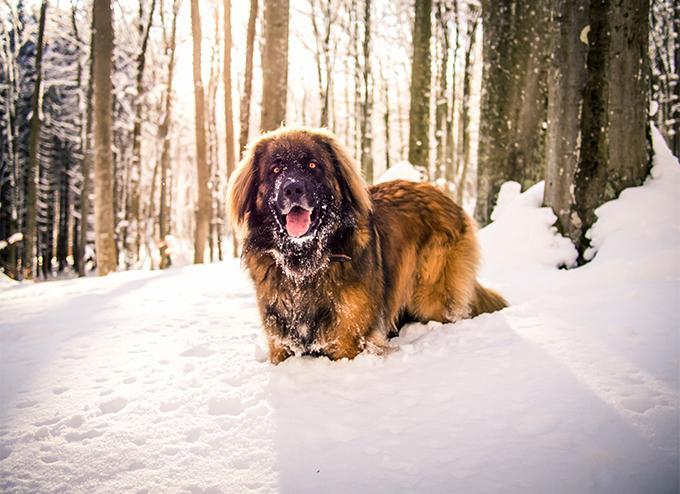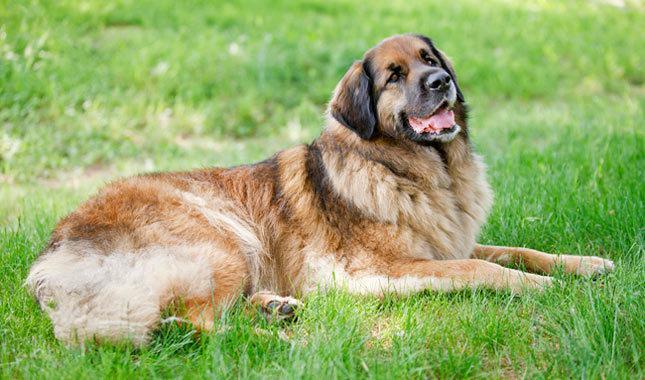The first image is the image on the left, the second image is the image on the right. Assess this claim about the two images: "An image shows a toddler girl next to a large dog.". Correct or not? Answer yes or no. No. 